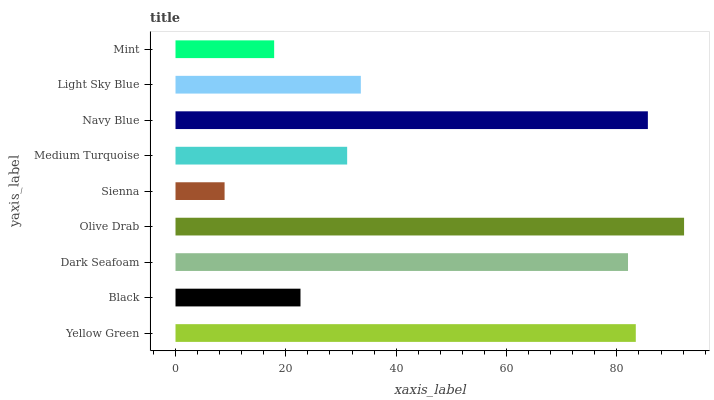Is Sienna the minimum?
Answer yes or no. Yes. Is Olive Drab the maximum?
Answer yes or no. Yes. Is Black the minimum?
Answer yes or no. No. Is Black the maximum?
Answer yes or no. No. Is Yellow Green greater than Black?
Answer yes or no. Yes. Is Black less than Yellow Green?
Answer yes or no. Yes. Is Black greater than Yellow Green?
Answer yes or no. No. Is Yellow Green less than Black?
Answer yes or no. No. Is Light Sky Blue the high median?
Answer yes or no. Yes. Is Light Sky Blue the low median?
Answer yes or no. Yes. Is Mint the high median?
Answer yes or no. No. Is Sienna the low median?
Answer yes or no. No. 